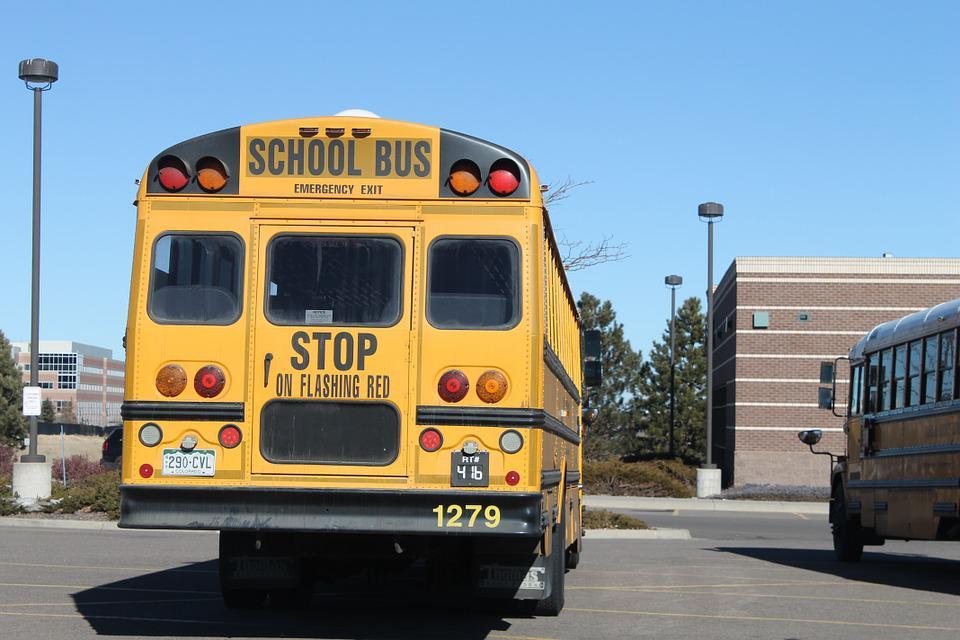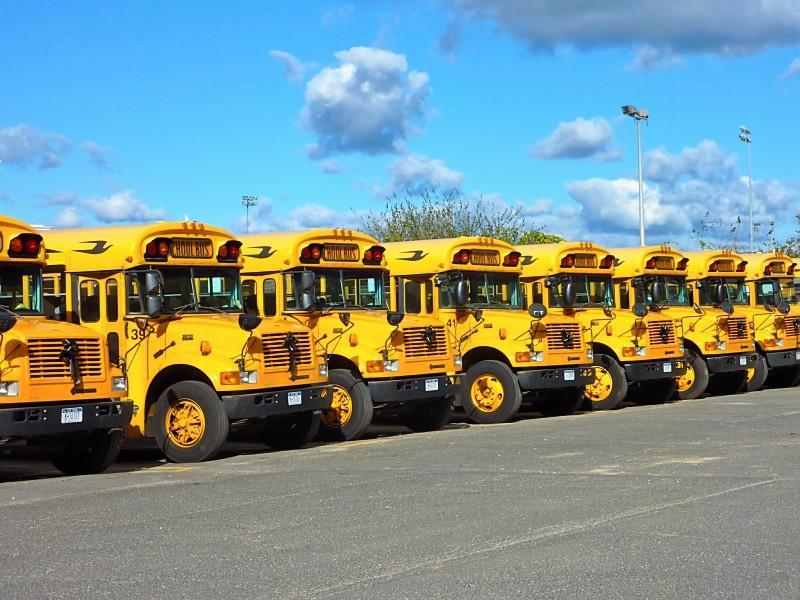The first image is the image on the left, the second image is the image on the right. Evaluate the accuracy of this statement regarding the images: "There are exactly two school buses.". Is it true? Answer yes or no. No. The first image is the image on the left, the second image is the image on the right. Evaluate the accuracy of this statement regarding the images: "One image shows a short leftward headed non-flat school bus with no more than five passenger windows per side, and the other image shows a short rightward angled bus from the rear.". Is it true? Answer yes or no. No. 